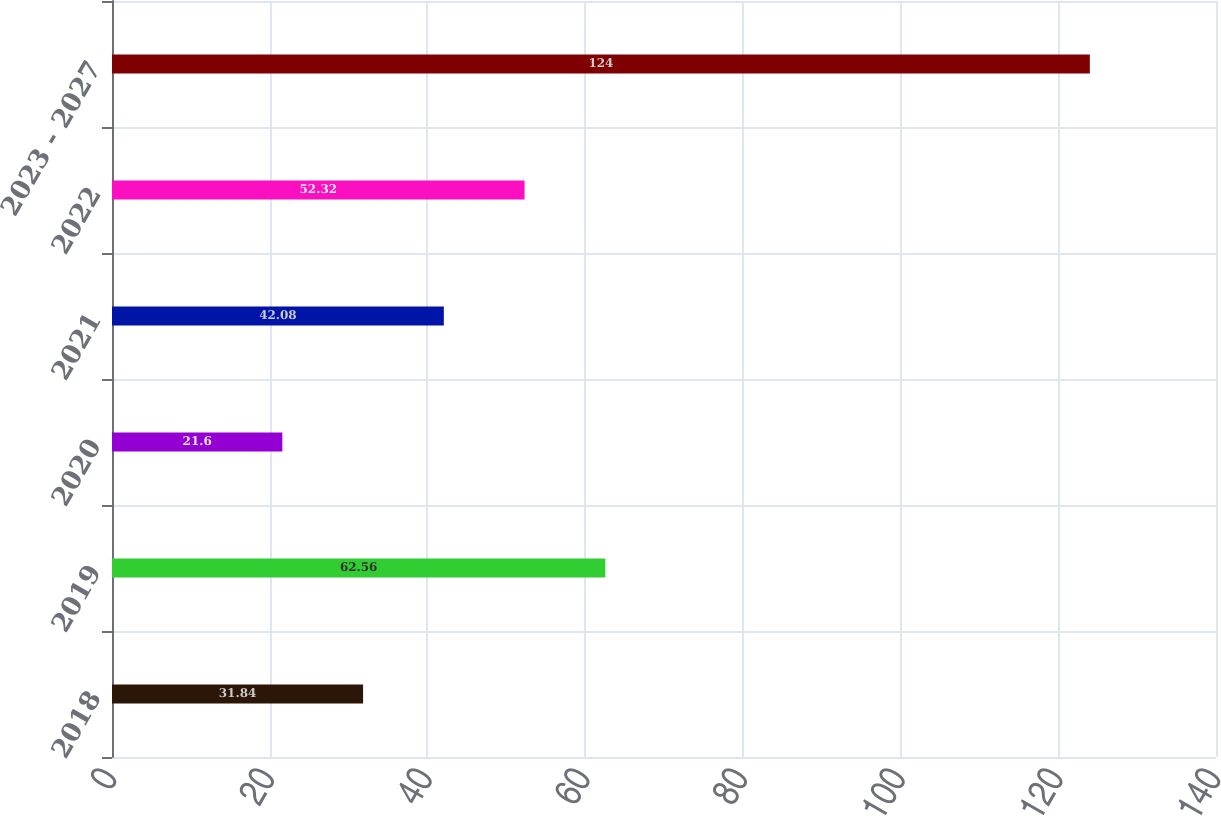<chart> <loc_0><loc_0><loc_500><loc_500><bar_chart><fcel>2018<fcel>2019<fcel>2020<fcel>2021<fcel>2022<fcel>2023 - 2027<nl><fcel>31.84<fcel>62.56<fcel>21.6<fcel>42.08<fcel>52.32<fcel>124<nl></chart> 